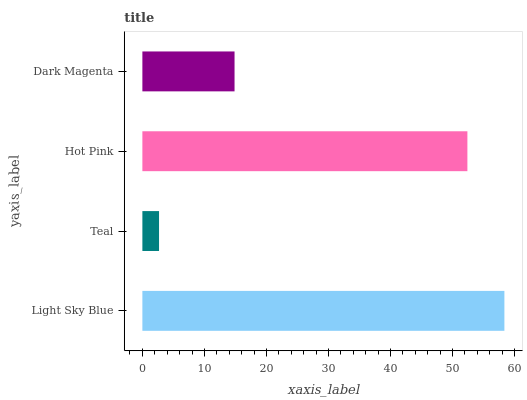Is Teal the minimum?
Answer yes or no. Yes. Is Light Sky Blue the maximum?
Answer yes or no. Yes. Is Hot Pink the minimum?
Answer yes or no. No. Is Hot Pink the maximum?
Answer yes or no. No. Is Hot Pink greater than Teal?
Answer yes or no. Yes. Is Teal less than Hot Pink?
Answer yes or no. Yes. Is Teal greater than Hot Pink?
Answer yes or no. No. Is Hot Pink less than Teal?
Answer yes or no. No. Is Hot Pink the high median?
Answer yes or no. Yes. Is Dark Magenta the low median?
Answer yes or no. Yes. Is Dark Magenta the high median?
Answer yes or no. No. Is Light Sky Blue the low median?
Answer yes or no. No. 